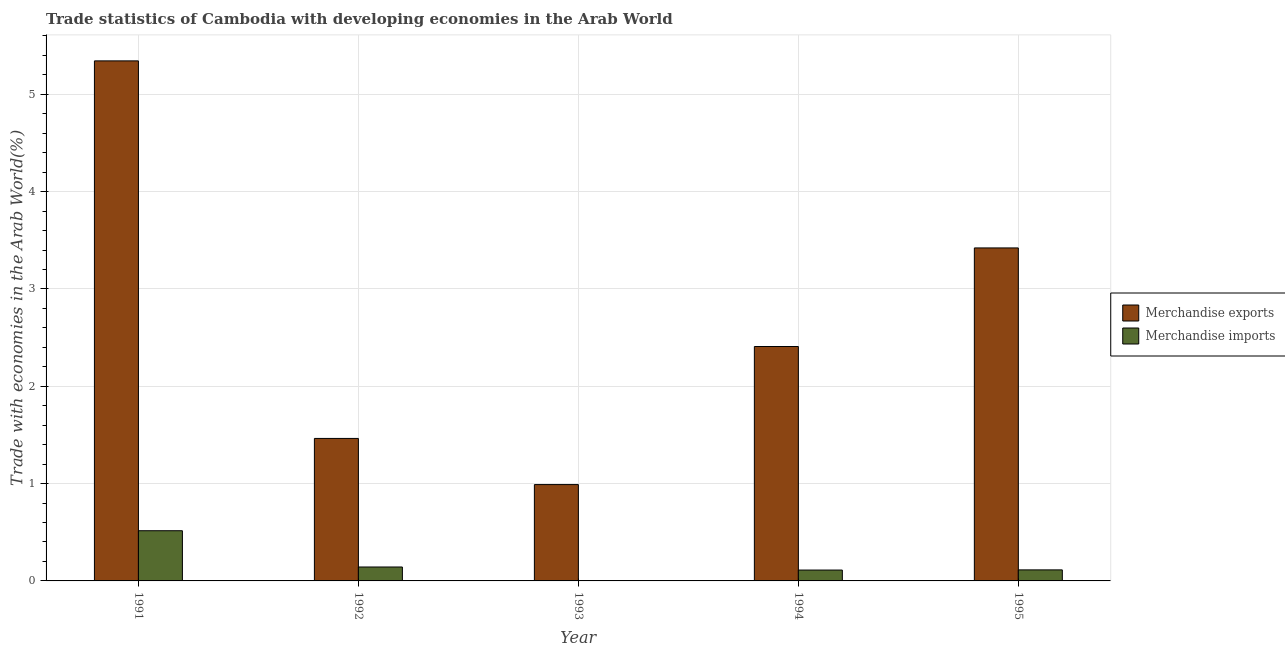How many different coloured bars are there?
Your answer should be very brief. 2. How many groups of bars are there?
Make the answer very short. 5. Are the number of bars per tick equal to the number of legend labels?
Your answer should be compact. Yes. What is the label of the 5th group of bars from the left?
Offer a very short reply. 1995. In how many cases, is the number of bars for a given year not equal to the number of legend labels?
Provide a succinct answer. 0. What is the merchandise imports in 1993?
Offer a very short reply. 0. Across all years, what is the maximum merchandise exports?
Give a very brief answer. 5.34. Across all years, what is the minimum merchandise exports?
Your response must be concise. 0.99. In which year was the merchandise imports minimum?
Keep it short and to the point. 1993. What is the total merchandise exports in the graph?
Your response must be concise. 13.63. What is the difference between the merchandise imports in 1992 and that in 1995?
Ensure brevity in your answer.  0.03. What is the difference between the merchandise imports in 1994 and the merchandise exports in 1993?
Keep it short and to the point. 0.11. What is the average merchandise imports per year?
Offer a very short reply. 0.18. In the year 1995, what is the difference between the merchandise imports and merchandise exports?
Give a very brief answer. 0. What is the ratio of the merchandise exports in 1993 to that in 1995?
Ensure brevity in your answer.  0.29. Is the merchandise imports in 1994 less than that in 1995?
Keep it short and to the point. Yes. What is the difference between the highest and the second highest merchandise imports?
Offer a terse response. 0.37. What is the difference between the highest and the lowest merchandise imports?
Your answer should be very brief. 0.51. In how many years, is the merchandise imports greater than the average merchandise imports taken over all years?
Offer a very short reply. 1. Is the sum of the merchandise imports in 1992 and 1993 greater than the maximum merchandise exports across all years?
Offer a terse response. No. What does the 2nd bar from the left in 1994 represents?
Make the answer very short. Merchandise imports. How many bars are there?
Your response must be concise. 10. How many years are there in the graph?
Ensure brevity in your answer.  5. What is the difference between two consecutive major ticks on the Y-axis?
Keep it short and to the point. 1. Does the graph contain any zero values?
Your answer should be compact. No. What is the title of the graph?
Offer a very short reply. Trade statistics of Cambodia with developing economies in the Arab World. Does "Register a property" appear as one of the legend labels in the graph?
Make the answer very short. No. What is the label or title of the X-axis?
Offer a very short reply. Year. What is the label or title of the Y-axis?
Keep it short and to the point. Trade with economies in the Arab World(%). What is the Trade with economies in the Arab World(%) in Merchandise exports in 1991?
Offer a terse response. 5.34. What is the Trade with economies in the Arab World(%) of Merchandise imports in 1991?
Your answer should be very brief. 0.52. What is the Trade with economies in the Arab World(%) in Merchandise exports in 1992?
Offer a very short reply. 1.46. What is the Trade with economies in the Arab World(%) of Merchandise imports in 1992?
Keep it short and to the point. 0.14. What is the Trade with economies in the Arab World(%) of Merchandise exports in 1993?
Your answer should be compact. 0.99. What is the Trade with economies in the Arab World(%) of Merchandise imports in 1993?
Make the answer very short. 0. What is the Trade with economies in the Arab World(%) of Merchandise exports in 1994?
Offer a very short reply. 2.41. What is the Trade with economies in the Arab World(%) in Merchandise imports in 1994?
Your answer should be very brief. 0.11. What is the Trade with economies in the Arab World(%) in Merchandise exports in 1995?
Provide a short and direct response. 3.42. What is the Trade with economies in the Arab World(%) in Merchandise imports in 1995?
Keep it short and to the point. 0.11. Across all years, what is the maximum Trade with economies in the Arab World(%) in Merchandise exports?
Provide a succinct answer. 5.34. Across all years, what is the maximum Trade with economies in the Arab World(%) of Merchandise imports?
Your answer should be compact. 0.52. Across all years, what is the minimum Trade with economies in the Arab World(%) of Merchandise exports?
Make the answer very short. 0.99. Across all years, what is the minimum Trade with economies in the Arab World(%) in Merchandise imports?
Keep it short and to the point. 0. What is the total Trade with economies in the Arab World(%) in Merchandise exports in the graph?
Offer a terse response. 13.63. What is the total Trade with economies in the Arab World(%) of Merchandise imports in the graph?
Ensure brevity in your answer.  0.89. What is the difference between the Trade with economies in the Arab World(%) in Merchandise exports in 1991 and that in 1992?
Give a very brief answer. 3.88. What is the difference between the Trade with economies in the Arab World(%) of Merchandise imports in 1991 and that in 1992?
Your response must be concise. 0.37. What is the difference between the Trade with economies in the Arab World(%) in Merchandise exports in 1991 and that in 1993?
Give a very brief answer. 4.35. What is the difference between the Trade with economies in the Arab World(%) in Merchandise imports in 1991 and that in 1993?
Provide a short and direct response. 0.51. What is the difference between the Trade with economies in the Arab World(%) in Merchandise exports in 1991 and that in 1994?
Your response must be concise. 2.94. What is the difference between the Trade with economies in the Arab World(%) of Merchandise imports in 1991 and that in 1994?
Provide a short and direct response. 0.4. What is the difference between the Trade with economies in the Arab World(%) of Merchandise exports in 1991 and that in 1995?
Provide a short and direct response. 1.92. What is the difference between the Trade with economies in the Arab World(%) of Merchandise imports in 1991 and that in 1995?
Offer a terse response. 0.4. What is the difference between the Trade with economies in the Arab World(%) of Merchandise exports in 1992 and that in 1993?
Offer a terse response. 0.47. What is the difference between the Trade with economies in the Arab World(%) of Merchandise imports in 1992 and that in 1993?
Your answer should be very brief. 0.14. What is the difference between the Trade with economies in the Arab World(%) of Merchandise exports in 1992 and that in 1994?
Make the answer very short. -0.94. What is the difference between the Trade with economies in the Arab World(%) in Merchandise imports in 1992 and that in 1994?
Keep it short and to the point. 0.03. What is the difference between the Trade with economies in the Arab World(%) in Merchandise exports in 1992 and that in 1995?
Your answer should be very brief. -1.96. What is the difference between the Trade with economies in the Arab World(%) in Merchandise imports in 1992 and that in 1995?
Your response must be concise. 0.03. What is the difference between the Trade with economies in the Arab World(%) of Merchandise exports in 1993 and that in 1994?
Provide a short and direct response. -1.42. What is the difference between the Trade with economies in the Arab World(%) of Merchandise imports in 1993 and that in 1994?
Offer a terse response. -0.11. What is the difference between the Trade with economies in the Arab World(%) of Merchandise exports in 1993 and that in 1995?
Provide a short and direct response. -2.43. What is the difference between the Trade with economies in the Arab World(%) of Merchandise imports in 1993 and that in 1995?
Your response must be concise. -0.11. What is the difference between the Trade with economies in the Arab World(%) in Merchandise exports in 1994 and that in 1995?
Provide a succinct answer. -1.01. What is the difference between the Trade with economies in the Arab World(%) of Merchandise imports in 1994 and that in 1995?
Your response must be concise. -0. What is the difference between the Trade with economies in the Arab World(%) of Merchandise exports in 1991 and the Trade with economies in the Arab World(%) of Merchandise imports in 1992?
Your response must be concise. 5.2. What is the difference between the Trade with economies in the Arab World(%) of Merchandise exports in 1991 and the Trade with economies in the Arab World(%) of Merchandise imports in 1993?
Make the answer very short. 5.34. What is the difference between the Trade with economies in the Arab World(%) in Merchandise exports in 1991 and the Trade with economies in the Arab World(%) in Merchandise imports in 1994?
Your answer should be compact. 5.23. What is the difference between the Trade with economies in the Arab World(%) in Merchandise exports in 1991 and the Trade with economies in the Arab World(%) in Merchandise imports in 1995?
Give a very brief answer. 5.23. What is the difference between the Trade with economies in the Arab World(%) in Merchandise exports in 1992 and the Trade with economies in the Arab World(%) in Merchandise imports in 1993?
Your answer should be compact. 1.46. What is the difference between the Trade with economies in the Arab World(%) of Merchandise exports in 1992 and the Trade with economies in the Arab World(%) of Merchandise imports in 1994?
Provide a succinct answer. 1.35. What is the difference between the Trade with economies in the Arab World(%) in Merchandise exports in 1992 and the Trade with economies in the Arab World(%) in Merchandise imports in 1995?
Make the answer very short. 1.35. What is the difference between the Trade with economies in the Arab World(%) of Merchandise exports in 1993 and the Trade with economies in the Arab World(%) of Merchandise imports in 1994?
Your answer should be compact. 0.88. What is the difference between the Trade with economies in the Arab World(%) of Merchandise exports in 1993 and the Trade with economies in the Arab World(%) of Merchandise imports in 1995?
Your answer should be very brief. 0.88. What is the difference between the Trade with economies in the Arab World(%) in Merchandise exports in 1994 and the Trade with economies in the Arab World(%) in Merchandise imports in 1995?
Provide a succinct answer. 2.3. What is the average Trade with economies in the Arab World(%) in Merchandise exports per year?
Your response must be concise. 2.73. What is the average Trade with economies in the Arab World(%) in Merchandise imports per year?
Your response must be concise. 0.18. In the year 1991, what is the difference between the Trade with economies in the Arab World(%) of Merchandise exports and Trade with economies in the Arab World(%) of Merchandise imports?
Ensure brevity in your answer.  4.83. In the year 1992, what is the difference between the Trade with economies in the Arab World(%) of Merchandise exports and Trade with economies in the Arab World(%) of Merchandise imports?
Ensure brevity in your answer.  1.32. In the year 1993, what is the difference between the Trade with economies in the Arab World(%) in Merchandise exports and Trade with economies in the Arab World(%) in Merchandise imports?
Your answer should be compact. 0.99. In the year 1994, what is the difference between the Trade with economies in the Arab World(%) of Merchandise exports and Trade with economies in the Arab World(%) of Merchandise imports?
Keep it short and to the point. 2.3. In the year 1995, what is the difference between the Trade with economies in the Arab World(%) of Merchandise exports and Trade with economies in the Arab World(%) of Merchandise imports?
Give a very brief answer. 3.31. What is the ratio of the Trade with economies in the Arab World(%) in Merchandise exports in 1991 to that in 1992?
Offer a terse response. 3.65. What is the ratio of the Trade with economies in the Arab World(%) of Merchandise imports in 1991 to that in 1992?
Offer a very short reply. 3.6. What is the ratio of the Trade with economies in the Arab World(%) in Merchandise exports in 1991 to that in 1993?
Your answer should be very brief. 5.4. What is the ratio of the Trade with economies in the Arab World(%) in Merchandise imports in 1991 to that in 1993?
Your response must be concise. 331.32. What is the ratio of the Trade with economies in the Arab World(%) of Merchandise exports in 1991 to that in 1994?
Give a very brief answer. 2.22. What is the ratio of the Trade with economies in the Arab World(%) of Merchandise imports in 1991 to that in 1994?
Offer a terse response. 4.62. What is the ratio of the Trade with economies in the Arab World(%) in Merchandise exports in 1991 to that in 1995?
Ensure brevity in your answer.  1.56. What is the ratio of the Trade with economies in the Arab World(%) of Merchandise imports in 1991 to that in 1995?
Make the answer very short. 4.55. What is the ratio of the Trade with economies in the Arab World(%) in Merchandise exports in 1992 to that in 1993?
Your response must be concise. 1.48. What is the ratio of the Trade with economies in the Arab World(%) of Merchandise imports in 1992 to that in 1993?
Your answer should be compact. 91.94. What is the ratio of the Trade with economies in the Arab World(%) in Merchandise exports in 1992 to that in 1994?
Provide a succinct answer. 0.61. What is the ratio of the Trade with economies in the Arab World(%) in Merchandise imports in 1992 to that in 1994?
Offer a very short reply. 1.28. What is the ratio of the Trade with economies in the Arab World(%) in Merchandise exports in 1992 to that in 1995?
Make the answer very short. 0.43. What is the ratio of the Trade with economies in the Arab World(%) in Merchandise imports in 1992 to that in 1995?
Give a very brief answer. 1.26. What is the ratio of the Trade with economies in the Arab World(%) of Merchandise exports in 1993 to that in 1994?
Give a very brief answer. 0.41. What is the ratio of the Trade with economies in the Arab World(%) of Merchandise imports in 1993 to that in 1994?
Ensure brevity in your answer.  0.01. What is the ratio of the Trade with economies in the Arab World(%) of Merchandise exports in 1993 to that in 1995?
Offer a very short reply. 0.29. What is the ratio of the Trade with economies in the Arab World(%) in Merchandise imports in 1993 to that in 1995?
Your answer should be very brief. 0.01. What is the ratio of the Trade with economies in the Arab World(%) in Merchandise exports in 1994 to that in 1995?
Offer a very short reply. 0.7. What is the ratio of the Trade with economies in the Arab World(%) of Merchandise imports in 1994 to that in 1995?
Keep it short and to the point. 0.98. What is the difference between the highest and the second highest Trade with economies in the Arab World(%) in Merchandise exports?
Offer a very short reply. 1.92. What is the difference between the highest and the second highest Trade with economies in the Arab World(%) in Merchandise imports?
Your response must be concise. 0.37. What is the difference between the highest and the lowest Trade with economies in the Arab World(%) of Merchandise exports?
Your response must be concise. 4.35. What is the difference between the highest and the lowest Trade with economies in the Arab World(%) in Merchandise imports?
Provide a succinct answer. 0.51. 